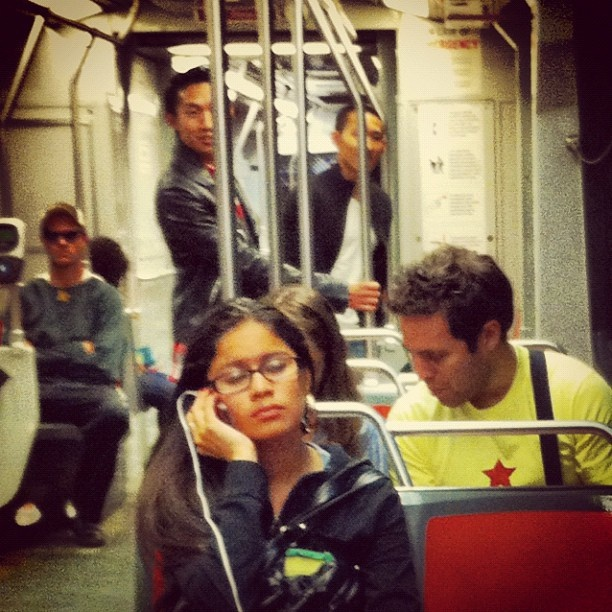Describe the objects in this image and their specific colors. I can see people in black, maroon, gray, and tan tones, people in black, khaki, and maroon tones, people in black, gray, and maroon tones, chair in black, maroon, and brown tones, and people in black, gray, maroon, and brown tones in this image. 